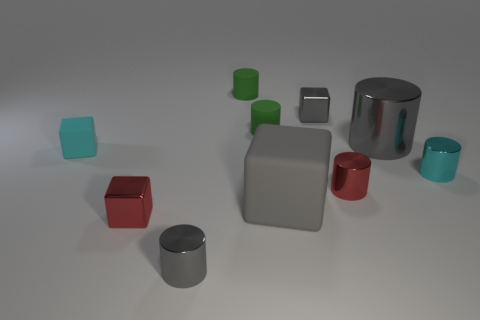Subtract all tiny cylinders. How many cylinders are left? 1 Subtract all cylinders. How many objects are left? 4 Subtract all gray blocks. How many blocks are left? 2 Subtract 2 cubes. How many cubes are left? 2 Subtract all purple cylinders. Subtract all red blocks. How many cylinders are left? 6 Subtract all brown blocks. How many yellow cylinders are left? 0 Subtract all red metallic cylinders. Subtract all gray things. How many objects are left? 5 Add 2 gray rubber things. How many gray rubber things are left? 3 Add 7 tiny red spheres. How many tiny red spheres exist? 7 Subtract 0 green blocks. How many objects are left? 10 